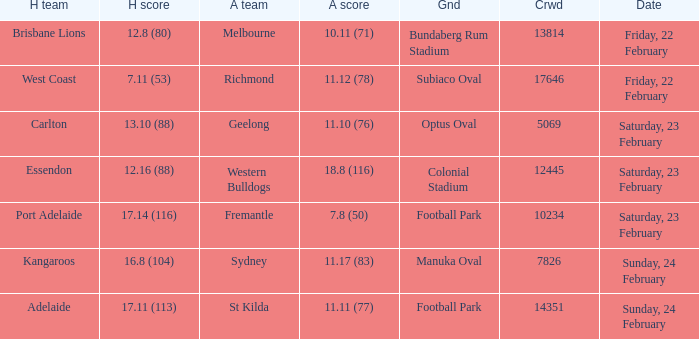What score did the away team receive against home team Port Adelaide? 7.8 (50). 